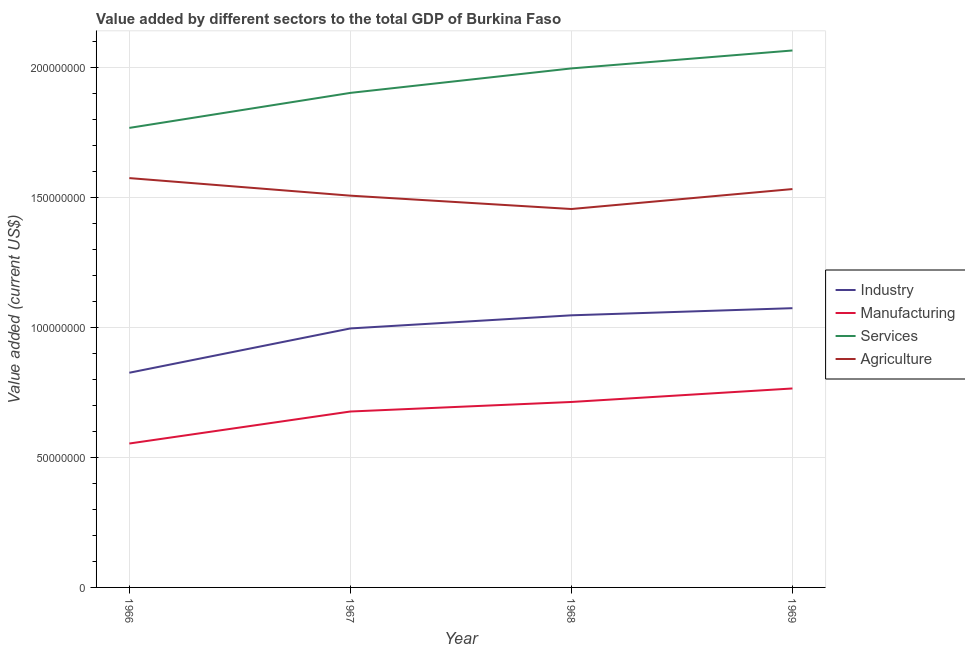Is the number of lines equal to the number of legend labels?
Provide a succinct answer. Yes. What is the value added by services sector in 1969?
Ensure brevity in your answer.  2.06e+08. Across all years, what is the maximum value added by manufacturing sector?
Your response must be concise. 7.65e+07. Across all years, what is the minimum value added by agricultural sector?
Provide a short and direct response. 1.45e+08. In which year was the value added by manufacturing sector maximum?
Make the answer very short. 1969. In which year was the value added by services sector minimum?
Provide a succinct answer. 1966. What is the total value added by services sector in the graph?
Keep it short and to the point. 7.73e+08. What is the difference between the value added by agricultural sector in 1966 and that in 1968?
Provide a short and direct response. 1.19e+07. What is the difference between the value added by services sector in 1966 and the value added by manufacturing sector in 1968?
Give a very brief answer. 1.05e+08. What is the average value added by agricultural sector per year?
Your response must be concise. 1.52e+08. In the year 1968, what is the difference between the value added by manufacturing sector and value added by agricultural sector?
Give a very brief answer. -7.42e+07. In how many years, is the value added by agricultural sector greater than 40000000 US$?
Your answer should be very brief. 4. What is the ratio of the value added by industrial sector in 1967 to that in 1969?
Ensure brevity in your answer.  0.93. What is the difference between the highest and the second highest value added by manufacturing sector?
Keep it short and to the point. 5.19e+06. What is the difference between the highest and the lowest value added by industrial sector?
Provide a short and direct response. 2.48e+07. Is the sum of the value added by agricultural sector in 1966 and 1969 greater than the maximum value added by manufacturing sector across all years?
Keep it short and to the point. Yes. Does the value added by industrial sector monotonically increase over the years?
Your response must be concise. Yes. Is the value added by services sector strictly greater than the value added by agricultural sector over the years?
Provide a succinct answer. Yes. Is the value added by services sector strictly less than the value added by manufacturing sector over the years?
Your answer should be compact. No. How many lines are there?
Give a very brief answer. 4. How many years are there in the graph?
Offer a very short reply. 4. What is the difference between two consecutive major ticks on the Y-axis?
Provide a succinct answer. 5.00e+07. Are the values on the major ticks of Y-axis written in scientific E-notation?
Provide a short and direct response. No. Does the graph contain any zero values?
Provide a short and direct response. No. How many legend labels are there?
Provide a succinct answer. 4. What is the title of the graph?
Provide a succinct answer. Value added by different sectors to the total GDP of Burkina Faso. Does "Pre-primary schools" appear as one of the legend labels in the graph?
Keep it short and to the point. No. What is the label or title of the X-axis?
Give a very brief answer. Year. What is the label or title of the Y-axis?
Your response must be concise. Value added (current US$). What is the Value added (current US$) in Industry in 1966?
Give a very brief answer. 8.25e+07. What is the Value added (current US$) in Manufacturing in 1966?
Provide a succinct answer. 5.53e+07. What is the Value added (current US$) in Services in 1966?
Offer a very short reply. 1.77e+08. What is the Value added (current US$) in Agriculture in 1966?
Provide a succinct answer. 1.57e+08. What is the Value added (current US$) in Industry in 1967?
Provide a succinct answer. 9.96e+07. What is the Value added (current US$) of Manufacturing in 1967?
Offer a very short reply. 6.76e+07. What is the Value added (current US$) of Services in 1967?
Give a very brief answer. 1.90e+08. What is the Value added (current US$) of Agriculture in 1967?
Keep it short and to the point. 1.51e+08. What is the Value added (current US$) of Industry in 1968?
Make the answer very short. 1.05e+08. What is the Value added (current US$) of Manufacturing in 1968?
Your response must be concise. 7.13e+07. What is the Value added (current US$) in Services in 1968?
Offer a terse response. 2.00e+08. What is the Value added (current US$) in Agriculture in 1968?
Provide a succinct answer. 1.45e+08. What is the Value added (current US$) in Industry in 1969?
Your answer should be compact. 1.07e+08. What is the Value added (current US$) of Manufacturing in 1969?
Offer a terse response. 7.65e+07. What is the Value added (current US$) in Services in 1969?
Give a very brief answer. 2.06e+08. What is the Value added (current US$) of Agriculture in 1969?
Offer a very short reply. 1.53e+08. Across all years, what is the maximum Value added (current US$) of Industry?
Offer a terse response. 1.07e+08. Across all years, what is the maximum Value added (current US$) in Manufacturing?
Offer a terse response. 7.65e+07. Across all years, what is the maximum Value added (current US$) of Services?
Offer a very short reply. 2.06e+08. Across all years, what is the maximum Value added (current US$) in Agriculture?
Your answer should be compact. 1.57e+08. Across all years, what is the minimum Value added (current US$) of Industry?
Provide a short and direct response. 8.25e+07. Across all years, what is the minimum Value added (current US$) of Manufacturing?
Offer a very short reply. 5.53e+07. Across all years, what is the minimum Value added (current US$) in Services?
Make the answer very short. 1.77e+08. Across all years, what is the minimum Value added (current US$) in Agriculture?
Give a very brief answer. 1.45e+08. What is the total Value added (current US$) of Industry in the graph?
Make the answer very short. 3.94e+08. What is the total Value added (current US$) in Manufacturing in the graph?
Offer a very short reply. 2.71e+08. What is the total Value added (current US$) in Services in the graph?
Make the answer very short. 7.73e+08. What is the total Value added (current US$) in Agriculture in the graph?
Provide a short and direct response. 6.07e+08. What is the difference between the Value added (current US$) of Industry in 1966 and that in 1967?
Your answer should be very brief. -1.70e+07. What is the difference between the Value added (current US$) of Manufacturing in 1966 and that in 1967?
Make the answer very short. -1.23e+07. What is the difference between the Value added (current US$) in Services in 1966 and that in 1967?
Offer a very short reply. -1.35e+07. What is the difference between the Value added (current US$) of Agriculture in 1966 and that in 1967?
Provide a short and direct response. 6.75e+06. What is the difference between the Value added (current US$) of Industry in 1966 and that in 1968?
Your response must be concise. -2.21e+07. What is the difference between the Value added (current US$) of Manufacturing in 1966 and that in 1968?
Offer a very short reply. -1.60e+07. What is the difference between the Value added (current US$) in Services in 1966 and that in 1968?
Provide a succinct answer. -2.29e+07. What is the difference between the Value added (current US$) in Agriculture in 1966 and that in 1968?
Keep it short and to the point. 1.19e+07. What is the difference between the Value added (current US$) of Industry in 1966 and that in 1969?
Offer a terse response. -2.48e+07. What is the difference between the Value added (current US$) of Manufacturing in 1966 and that in 1969?
Your answer should be compact. -2.12e+07. What is the difference between the Value added (current US$) in Services in 1966 and that in 1969?
Give a very brief answer. -2.98e+07. What is the difference between the Value added (current US$) in Agriculture in 1966 and that in 1969?
Keep it short and to the point. 4.22e+06. What is the difference between the Value added (current US$) in Industry in 1967 and that in 1968?
Your answer should be compact. -5.04e+06. What is the difference between the Value added (current US$) in Manufacturing in 1967 and that in 1968?
Give a very brief answer. -3.67e+06. What is the difference between the Value added (current US$) in Services in 1967 and that in 1968?
Ensure brevity in your answer.  -9.41e+06. What is the difference between the Value added (current US$) of Agriculture in 1967 and that in 1968?
Ensure brevity in your answer.  5.13e+06. What is the difference between the Value added (current US$) of Industry in 1967 and that in 1969?
Provide a succinct answer. -7.79e+06. What is the difference between the Value added (current US$) of Manufacturing in 1967 and that in 1969?
Your response must be concise. -8.86e+06. What is the difference between the Value added (current US$) in Services in 1967 and that in 1969?
Provide a short and direct response. -1.63e+07. What is the difference between the Value added (current US$) of Agriculture in 1967 and that in 1969?
Your response must be concise. -2.53e+06. What is the difference between the Value added (current US$) of Industry in 1968 and that in 1969?
Your response must be concise. -2.74e+06. What is the difference between the Value added (current US$) in Manufacturing in 1968 and that in 1969?
Keep it short and to the point. -5.19e+06. What is the difference between the Value added (current US$) of Services in 1968 and that in 1969?
Your response must be concise. -6.90e+06. What is the difference between the Value added (current US$) of Agriculture in 1968 and that in 1969?
Provide a succinct answer. -7.67e+06. What is the difference between the Value added (current US$) of Industry in 1966 and the Value added (current US$) of Manufacturing in 1967?
Your answer should be very brief. 1.49e+07. What is the difference between the Value added (current US$) of Industry in 1966 and the Value added (current US$) of Services in 1967?
Your answer should be very brief. -1.08e+08. What is the difference between the Value added (current US$) of Industry in 1966 and the Value added (current US$) of Agriculture in 1967?
Make the answer very short. -6.81e+07. What is the difference between the Value added (current US$) in Manufacturing in 1966 and the Value added (current US$) in Services in 1967?
Make the answer very short. -1.35e+08. What is the difference between the Value added (current US$) of Manufacturing in 1966 and the Value added (current US$) of Agriculture in 1967?
Ensure brevity in your answer.  -9.53e+07. What is the difference between the Value added (current US$) of Services in 1966 and the Value added (current US$) of Agriculture in 1967?
Your response must be concise. 2.61e+07. What is the difference between the Value added (current US$) in Industry in 1966 and the Value added (current US$) in Manufacturing in 1968?
Provide a succinct answer. 1.12e+07. What is the difference between the Value added (current US$) in Industry in 1966 and the Value added (current US$) in Services in 1968?
Your response must be concise. -1.17e+08. What is the difference between the Value added (current US$) in Industry in 1966 and the Value added (current US$) in Agriculture in 1968?
Provide a succinct answer. -6.29e+07. What is the difference between the Value added (current US$) in Manufacturing in 1966 and the Value added (current US$) in Services in 1968?
Keep it short and to the point. -1.44e+08. What is the difference between the Value added (current US$) of Manufacturing in 1966 and the Value added (current US$) of Agriculture in 1968?
Your answer should be very brief. -9.01e+07. What is the difference between the Value added (current US$) of Services in 1966 and the Value added (current US$) of Agriculture in 1968?
Offer a terse response. 3.12e+07. What is the difference between the Value added (current US$) in Industry in 1966 and the Value added (current US$) in Manufacturing in 1969?
Provide a short and direct response. 6.05e+06. What is the difference between the Value added (current US$) in Industry in 1966 and the Value added (current US$) in Services in 1969?
Your response must be concise. -1.24e+08. What is the difference between the Value added (current US$) of Industry in 1966 and the Value added (current US$) of Agriculture in 1969?
Offer a very short reply. -7.06e+07. What is the difference between the Value added (current US$) in Manufacturing in 1966 and the Value added (current US$) in Services in 1969?
Your response must be concise. -1.51e+08. What is the difference between the Value added (current US$) in Manufacturing in 1966 and the Value added (current US$) in Agriculture in 1969?
Ensure brevity in your answer.  -9.78e+07. What is the difference between the Value added (current US$) of Services in 1966 and the Value added (current US$) of Agriculture in 1969?
Your response must be concise. 2.35e+07. What is the difference between the Value added (current US$) of Industry in 1967 and the Value added (current US$) of Manufacturing in 1968?
Make the answer very short. 2.83e+07. What is the difference between the Value added (current US$) in Industry in 1967 and the Value added (current US$) in Services in 1968?
Your answer should be compact. -1.00e+08. What is the difference between the Value added (current US$) in Industry in 1967 and the Value added (current US$) in Agriculture in 1968?
Provide a short and direct response. -4.59e+07. What is the difference between the Value added (current US$) in Manufacturing in 1967 and the Value added (current US$) in Services in 1968?
Your answer should be very brief. -1.32e+08. What is the difference between the Value added (current US$) of Manufacturing in 1967 and the Value added (current US$) of Agriculture in 1968?
Provide a short and direct response. -7.78e+07. What is the difference between the Value added (current US$) of Services in 1967 and the Value added (current US$) of Agriculture in 1968?
Your response must be concise. 4.46e+07. What is the difference between the Value added (current US$) in Industry in 1967 and the Value added (current US$) in Manufacturing in 1969?
Keep it short and to the point. 2.31e+07. What is the difference between the Value added (current US$) of Industry in 1967 and the Value added (current US$) of Services in 1969?
Give a very brief answer. -1.07e+08. What is the difference between the Value added (current US$) in Industry in 1967 and the Value added (current US$) in Agriculture in 1969?
Ensure brevity in your answer.  -5.36e+07. What is the difference between the Value added (current US$) of Manufacturing in 1967 and the Value added (current US$) of Services in 1969?
Give a very brief answer. -1.39e+08. What is the difference between the Value added (current US$) in Manufacturing in 1967 and the Value added (current US$) in Agriculture in 1969?
Offer a very short reply. -8.55e+07. What is the difference between the Value added (current US$) of Services in 1967 and the Value added (current US$) of Agriculture in 1969?
Offer a very short reply. 3.70e+07. What is the difference between the Value added (current US$) of Industry in 1968 and the Value added (current US$) of Manufacturing in 1969?
Offer a terse response. 2.81e+07. What is the difference between the Value added (current US$) in Industry in 1968 and the Value added (current US$) in Services in 1969?
Your answer should be very brief. -1.02e+08. What is the difference between the Value added (current US$) in Industry in 1968 and the Value added (current US$) in Agriculture in 1969?
Your answer should be very brief. -4.85e+07. What is the difference between the Value added (current US$) in Manufacturing in 1968 and the Value added (current US$) in Services in 1969?
Keep it short and to the point. -1.35e+08. What is the difference between the Value added (current US$) of Manufacturing in 1968 and the Value added (current US$) of Agriculture in 1969?
Your response must be concise. -8.18e+07. What is the difference between the Value added (current US$) of Services in 1968 and the Value added (current US$) of Agriculture in 1969?
Offer a terse response. 4.64e+07. What is the average Value added (current US$) in Industry per year?
Keep it short and to the point. 9.85e+07. What is the average Value added (current US$) in Manufacturing per year?
Your answer should be very brief. 6.77e+07. What is the average Value added (current US$) in Services per year?
Offer a very short reply. 1.93e+08. What is the average Value added (current US$) in Agriculture per year?
Provide a succinct answer. 1.52e+08. In the year 1966, what is the difference between the Value added (current US$) of Industry and Value added (current US$) of Manufacturing?
Make the answer very short. 2.72e+07. In the year 1966, what is the difference between the Value added (current US$) of Industry and Value added (current US$) of Services?
Keep it short and to the point. -9.41e+07. In the year 1966, what is the difference between the Value added (current US$) in Industry and Value added (current US$) in Agriculture?
Your response must be concise. -7.48e+07. In the year 1966, what is the difference between the Value added (current US$) in Manufacturing and Value added (current US$) in Services?
Offer a terse response. -1.21e+08. In the year 1966, what is the difference between the Value added (current US$) of Manufacturing and Value added (current US$) of Agriculture?
Offer a very short reply. -1.02e+08. In the year 1966, what is the difference between the Value added (current US$) of Services and Value added (current US$) of Agriculture?
Give a very brief answer. 1.93e+07. In the year 1967, what is the difference between the Value added (current US$) in Industry and Value added (current US$) in Manufacturing?
Your response must be concise. 3.19e+07. In the year 1967, what is the difference between the Value added (current US$) of Industry and Value added (current US$) of Services?
Provide a short and direct response. -9.06e+07. In the year 1967, what is the difference between the Value added (current US$) of Industry and Value added (current US$) of Agriculture?
Provide a succinct answer. -5.10e+07. In the year 1967, what is the difference between the Value added (current US$) in Manufacturing and Value added (current US$) in Services?
Your response must be concise. -1.22e+08. In the year 1967, what is the difference between the Value added (current US$) in Manufacturing and Value added (current US$) in Agriculture?
Provide a succinct answer. -8.30e+07. In the year 1967, what is the difference between the Value added (current US$) in Services and Value added (current US$) in Agriculture?
Your answer should be very brief. 3.95e+07. In the year 1968, what is the difference between the Value added (current US$) of Industry and Value added (current US$) of Manufacturing?
Provide a succinct answer. 3.33e+07. In the year 1968, what is the difference between the Value added (current US$) in Industry and Value added (current US$) in Services?
Offer a very short reply. -9.49e+07. In the year 1968, what is the difference between the Value added (current US$) in Industry and Value added (current US$) in Agriculture?
Provide a succinct answer. -4.09e+07. In the year 1968, what is the difference between the Value added (current US$) in Manufacturing and Value added (current US$) in Services?
Keep it short and to the point. -1.28e+08. In the year 1968, what is the difference between the Value added (current US$) of Manufacturing and Value added (current US$) of Agriculture?
Your answer should be very brief. -7.42e+07. In the year 1968, what is the difference between the Value added (current US$) in Services and Value added (current US$) in Agriculture?
Ensure brevity in your answer.  5.41e+07. In the year 1969, what is the difference between the Value added (current US$) in Industry and Value added (current US$) in Manufacturing?
Ensure brevity in your answer.  3.09e+07. In the year 1969, what is the difference between the Value added (current US$) in Industry and Value added (current US$) in Services?
Your answer should be compact. -9.91e+07. In the year 1969, what is the difference between the Value added (current US$) in Industry and Value added (current US$) in Agriculture?
Offer a terse response. -4.58e+07. In the year 1969, what is the difference between the Value added (current US$) in Manufacturing and Value added (current US$) in Services?
Make the answer very short. -1.30e+08. In the year 1969, what is the difference between the Value added (current US$) of Manufacturing and Value added (current US$) of Agriculture?
Ensure brevity in your answer.  -7.67e+07. In the year 1969, what is the difference between the Value added (current US$) of Services and Value added (current US$) of Agriculture?
Ensure brevity in your answer.  5.33e+07. What is the ratio of the Value added (current US$) of Industry in 1966 to that in 1967?
Provide a short and direct response. 0.83. What is the ratio of the Value added (current US$) of Manufacturing in 1966 to that in 1967?
Your response must be concise. 0.82. What is the ratio of the Value added (current US$) in Services in 1966 to that in 1967?
Ensure brevity in your answer.  0.93. What is the ratio of the Value added (current US$) in Agriculture in 1966 to that in 1967?
Make the answer very short. 1.04. What is the ratio of the Value added (current US$) in Industry in 1966 to that in 1968?
Give a very brief answer. 0.79. What is the ratio of the Value added (current US$) of Manufacturing in 1966 to that in 1968?
Your answer should be very brief. 0.78. What is the ratio of the Value added (current US$) of Services in 1966 to that in 1968?
Make the answer very short. 0.89. What is the ratio of the Value added (current US$) of Agriculture in 1966 to that in 1968?
Offer a very short reply. 1.08. What is the ratio of the Value added (current US$) in Industry in 1966 to that in 1969?
Provide a short and direct response. 0.77. What is the ratio of the Value added (current US$) of Manufacturing in 1966 to that in 1969?
Provide a succinct answer. 0.72. What is the ratio of the Value added (current US$) of Services in 1966 to that in 1969?
Provide a succinct answer. 0.86. What is the ratio of the Value added (current US$) in Agriculture in 1966 to that in 1969?
Provide a succinct answer. 1.03. What is the ratio of the Value added (current US$) of Industry in 1967 to that in 1968?
Keep it short and to the point. 0.95. What is the ratio of the Value added (current US$) in Manufacturing in 1967 to that in 1968?
Give a very brief answer. 0.95. What is the ratio of the Value added (current US$) in Services in 1967 to that in 1968?
Provide a short and direct response. 0.95. What is the ratio of the Value added (current US$) of Agriculture in 1967 to that in 1968?
Ensure brevity in your answer.  1.04. What is the ratio of the Value added (current US$) of Industry in 1967 to that in 1969?
Provide a short and direct response. 0.93. What is the ratio of the Value added (current US$) in Manufacturing in 1967 to that in 1969?
Your answer should be very brief. 0.88. What is the ratio of the Value added (current US$) in Services in 1967 to that in 1969?
Make the answer very short. 0.92. What is the ratio of the Value added (current US$) of Agriculture in 1967 to that in 1969?
Provide a succinct answer. 0.98. What is the ratio of the Value added (current US$) of Industry in 1968 to that in 1969?
Give a very brief answer. 0.97. What is the ratio of the Value added (current US$) in Manufacturing in 1968 to that in 1969?
Offer a very short reply. 0.93. What is the ratio of the Value added (current US$) in Services in 1968 to that in 1969?
Keep it short and to the point. 0.97. What is the ratio of the Value added (current US$) in Agriculture in 1968 to that in 1969?
Give a very brief answer. 0.95. What is the difference between the highest and the second highest Value added (current US$) in Industry?
Keep it short and to the point. 2.74e+06. What is the difference between the highest and the second highest Value added (current US$) of Manufacturing?
Your answer should be compact. 5.19e+06. What is the difference between the highest and the second highest Value added (current US$) in Services?
Offer a terse response. 6.90e+06. What is the difference between the highest and the second highest Value added (current US$) of Agriculture?
Provide a succinct answer. 4.22e+06. What is the difference between the highest and the lowest Value added (current US$) of Industry?
Provide a succinct answer. 2.48e+07. What is the difference between the highest and the lowest Value added (current US$) of Manufacturing?
Ensure brevity in your answer.  2.12e+07. What is the difference between the highest and the lowest Value added (current US$) in Services?
Your answer should be very brief. 2.98e+07. What is the difference between the highest and the lowest Value added (current US$) in Agriculture?
Ensure brevity in your answer.  1.19e+07. 